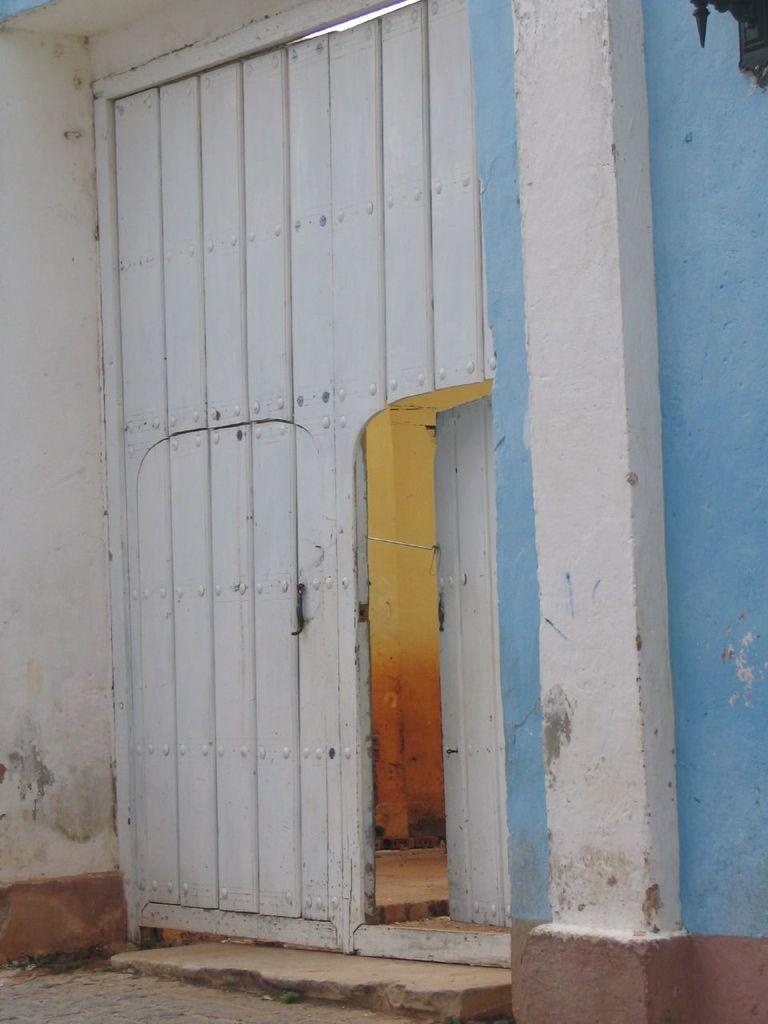What type of door is visible in the image? There is a white color wooden door in the image. What color is the wall next to the door? The wall next to the door is blue. How many snails can be seen crawling on the door in the image? There are no snails visible on the door in the image. What song is being played in the background of the image? There is no information about any song being played in the image. 